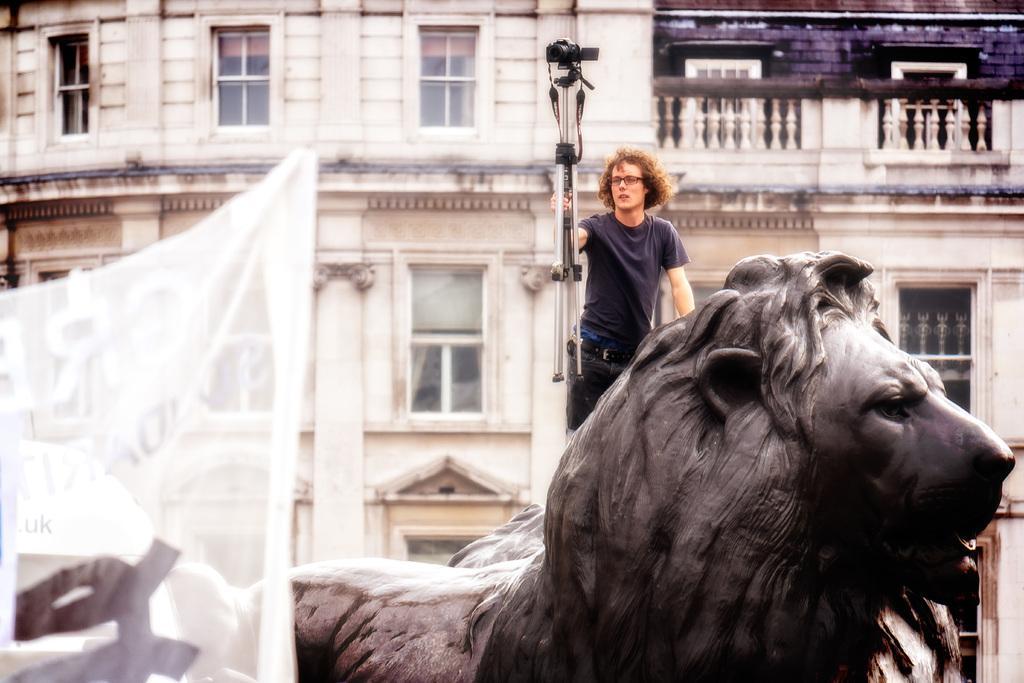Describe this image in one or two sentences. Here in this picture we can see a person standing on a lion statue present over there, we can see he is carrying a tripod in his hand with a video camera on it present over there and behind him we can see a building present and we can see windows on it over there and in the front we can see a banner present over there. 